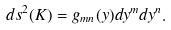Convert formula to latex. <formula><loc_0><loc_0><loc_500><loc_500>d s ^ { 2 } ( K ) = g _ { m n } ( y ) d y ^ { m } d y ^ { n } .</formula> 